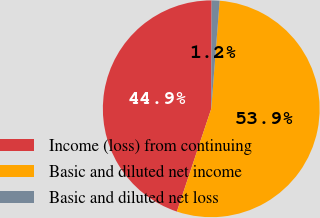Convert chart to OTSL. <chart><loc_0><loc_0><loc_500><loc_500><pie_chart><fcel>Income (loss) from continuing<fcel>Basic and diluted net income<fcel>Basic and diluted net loss<nl><fcel>44.92%<fcel>53.9%<fcel>1.18%<nl></chart> 